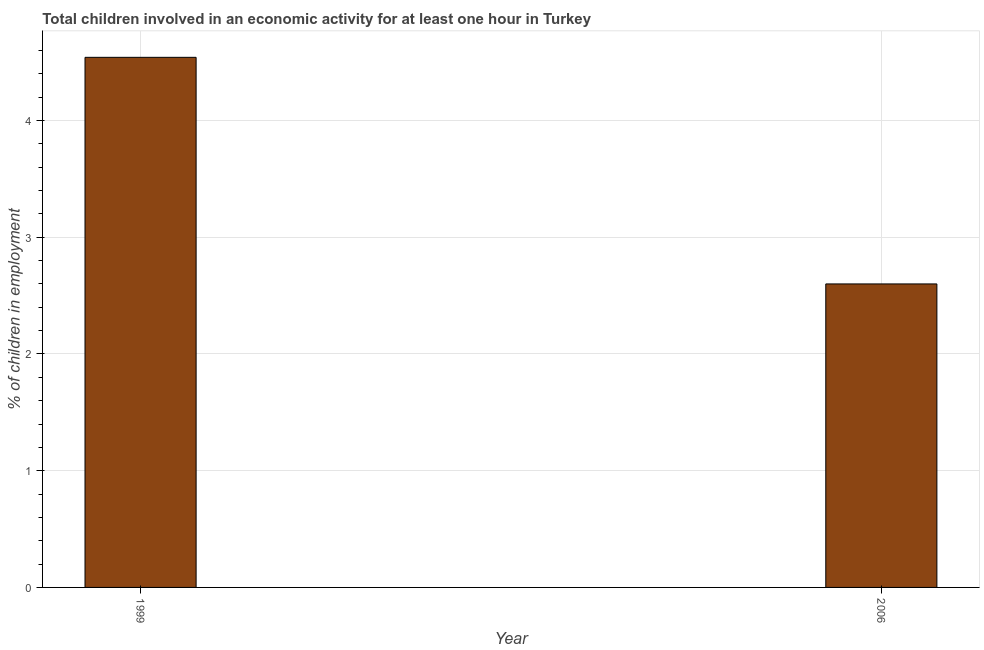Does the graph contain any zero values?
Your response must be concise. No. What is the title of the graph?
Give a very brief answer. Total children involved in an economic activity for at least one hour in Turkey. What is the label or title of the X-axis?
Your answer should be compact. Year. What is the label or title of the Y-axis?
Give a very brief answer. % of children in employment. What is the percentage of children in employment in 2006?
Keep it short and to the point. 2.6. Across all years, what is the maximum percentage of children in employment?
Provide a succinct answer. 4.54. In which year was the percentage of children in employment maximum?
Offer a very short reply. 1999. In which year was the percentage of children in employment minimum?
Offer a very short reply. 2006. What is the sum of the percentage of children in employment?
Offer a very short reply. 7.14. What is the difference between the percentage of children in employment in 1999 and 2006?
Provide a short and direct response. 1.94. What is the average percentage of children in employment per year?
Give a very brief answer. 3.57. What is the median percentage of children in employment?
Your response must be concise. 3.57. Do a majority of the years between 1999 and 2006 (inclusive) have percentage of children in employment greater than 4.2 %?
Provide a succinct answer. No. What is the ratio of the percentage of children in employment in 1999 to that in 2006?
Keep it short and to the point. 1.75. Is the percentage of children in employment in 1999 less than that in 2006?
Provide a succinct answer. No. How many bars are there?
Provide a succinct answer. 2. What is the difference between two consecutive major ticks on the Y-axis?
Offer a very short reply. 1. Are the values on the major ticks of Y-axis written in scientific E-notation?
Your response must be concise. No. What is the % of children in employment of 1999?
Offer a terse response. 4.54. What is the difference between the % of children in employment in 1999 and 2006?
Your response must be concise. 1.94. What is the ratio of the % of children in employment in 1999 to that in 2006?
Give a very brief answer. 1.75. 